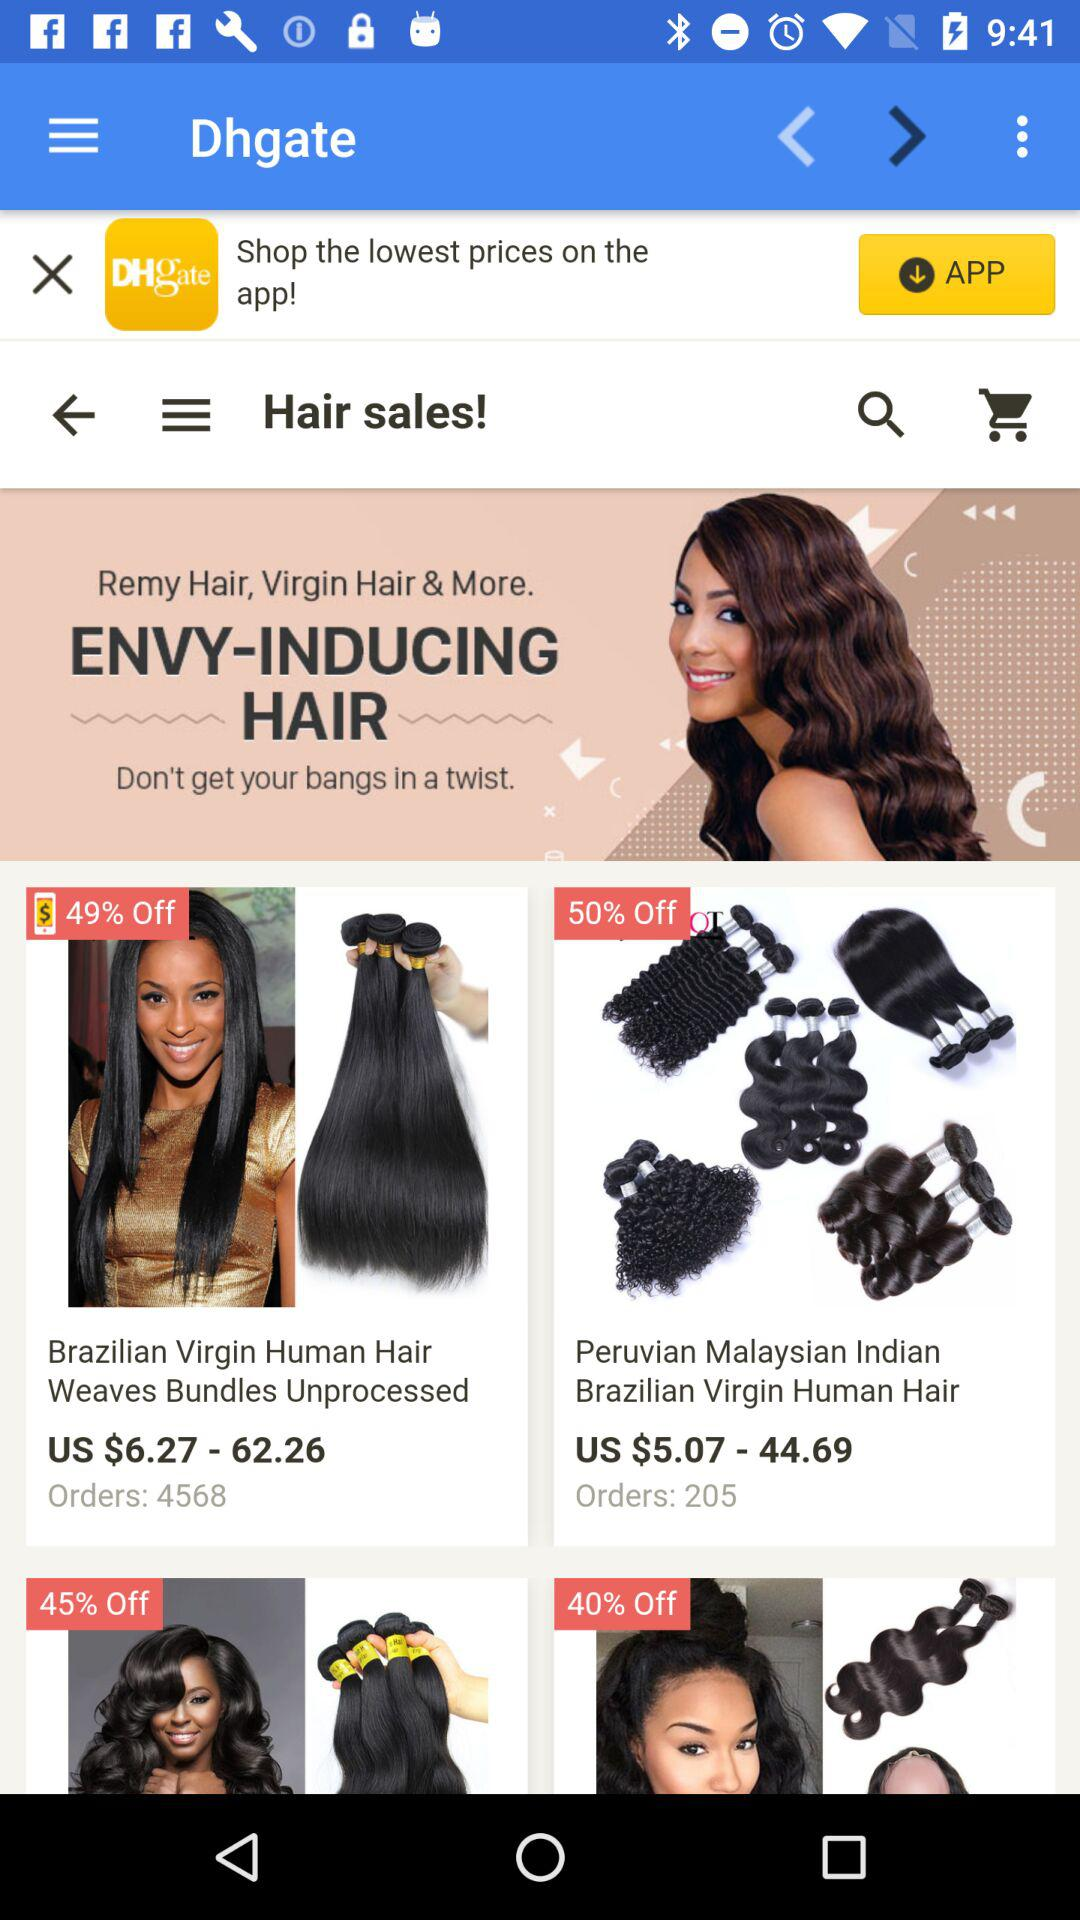What is the discount on Brazilian Virgin Human Hair? The discount is 49% off. 